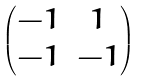Convert formula to latex. <formula><loc_0><loc_0><loc_500><loc_500>\begin{pmatrix} - 1 & 1 \\ - 1 & - 1 \end{pmatrix}</formula> 